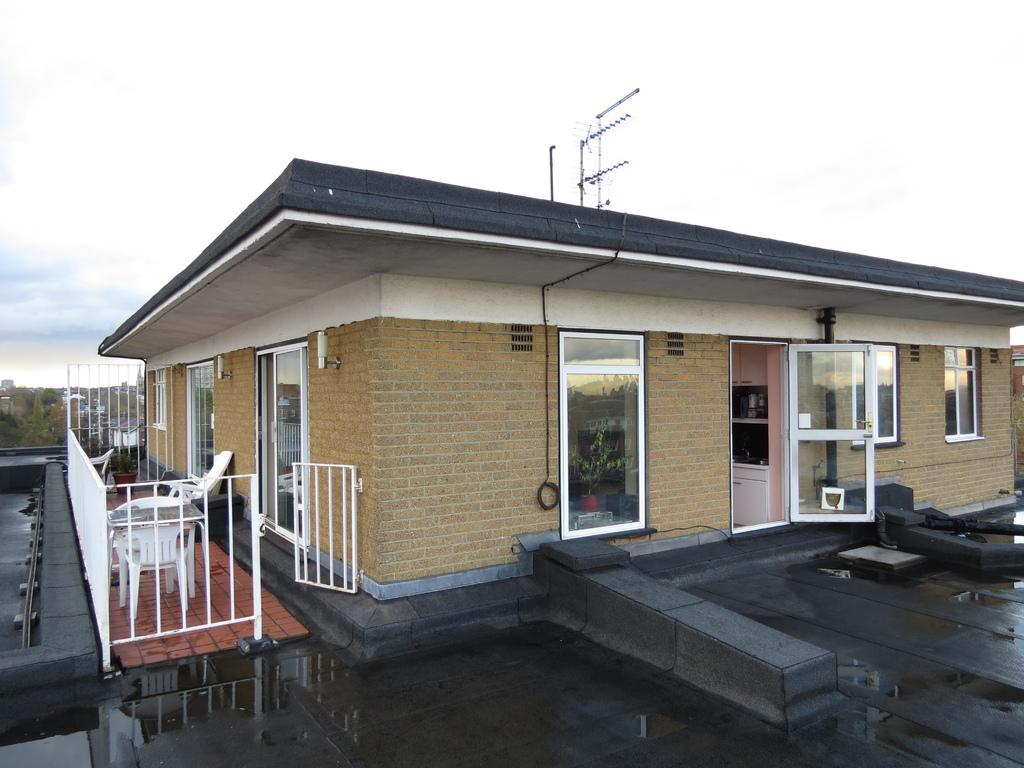What colors can be seen on the building in the image? The building in the image is brown, cream, and white in color. What feature can be seen on the building that might be used for safety or support? There is a railing in the image. What type of furniture is visible in the image? A chair is visible in the image. How many doors are present on the building in the image? There are doors on the building. What type of communication device is present on the building in the image? There is an antenna on the building. What can be seen in the background of the image? The sky is visible in the background of the image. What type of yam is being shown in the image? There is no yam present in the image; it features a building with various details. Can you describe the man standing next to the building in the image? There is no man present in the image; it only features the building and its surroundings. 